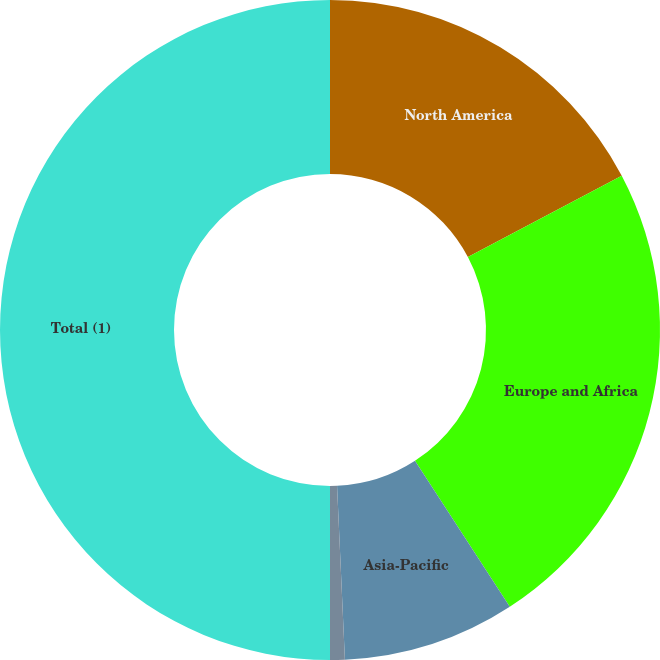<chart> <loc_0><loc_0><loc_500><loc_500><pie_chart><fcel>North America<fcel>Europe and Africa<fcel>Asia-Pacific<fcel>South America<fcel>Total (1)<nl><fcel>17.26%<fcel>23.57%<fcel>8.45%<fcel>0.72%<fcel>50.0%<nl></chart> 